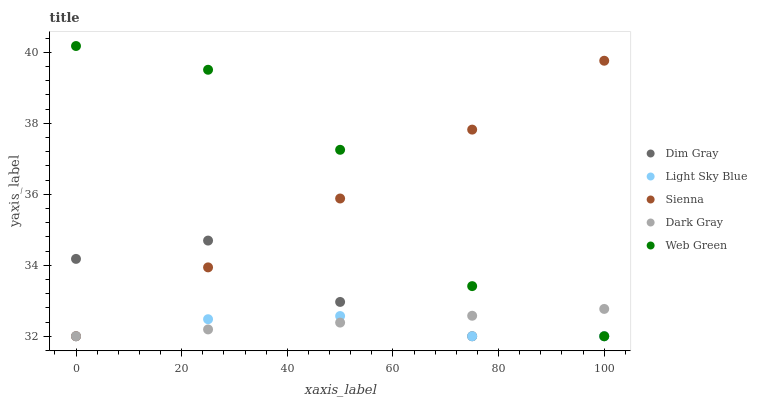Does Light Sky Blue have the minimum area under the curve?
Answer yes or no. Yes. Does Web Green have the maximum area under the curve?
Answer yes or no. Yes. Does Dark Gray have the minimum area under the curve?
Answer yes or no. No. Does Dark Gray have the maximum area under the curve?
Answer yes or no. No. Is Sienna the smoothest?
Answer yes or no. Yes. Is Web Green the roughest?
Answer yes or no. Yes. Is Dark Gray the smoothest?
Answer yes or no. No. Is Dark Gray the roughest?
Answer yes or no. No. Does Sienna have the lowest value?
Answer yes or no. Yes. Does Web Green have the highest value?
Answer yes or no. Yes. Does Dark Gray have the highest value?
Answer yes or no. No. Does Dark Gray intersect Sienna?
Answer yes or no. Yes. Is Dark Gray less than Sienna?
Answer yes or no. No. Is Dark Gray greater than Sienna?
Answer yes or no. No. 